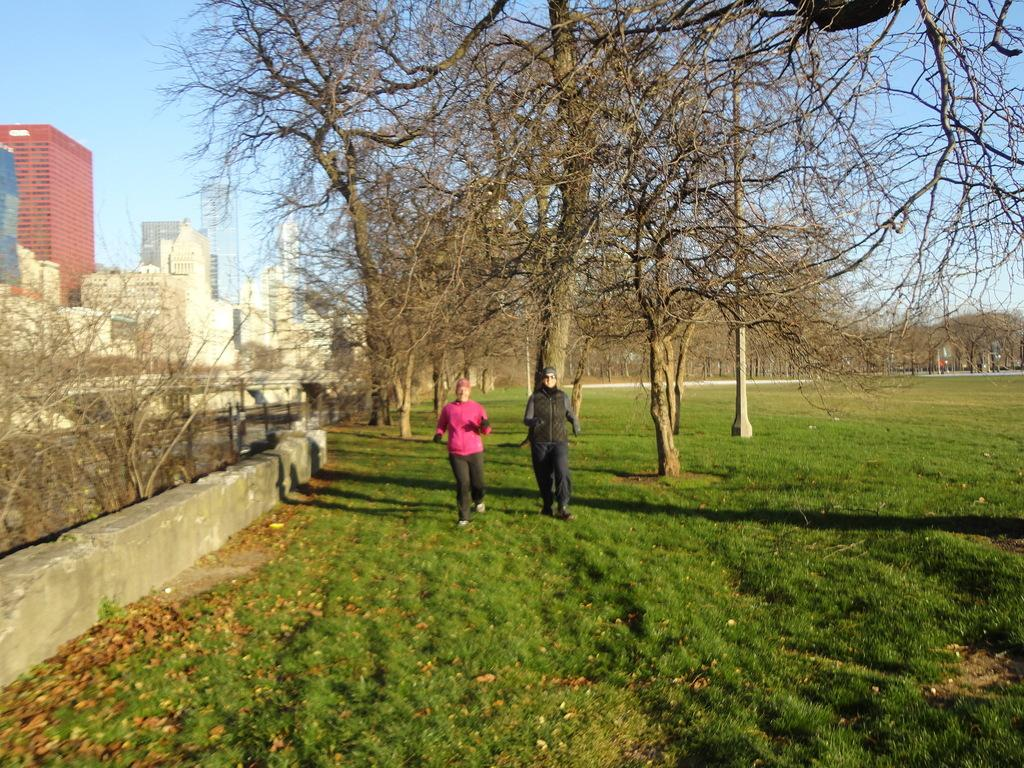How many people are present in the image? There are 2 persons in the image. What type of natural environment is visible in the image? There is green grass in the image. What can be seen in the background of the image? There are trees and buildings in the background of the image. What is the color of the sky in the background of the image? The sky is blue in the background of the image. What type of vessel is being used by the persons in the image? There is no vessel present in the image; the persons are standing on green grass. What type of vacation destination is depicted in the image? The image does not depict a specific vacation destination; it simply shows a scene with green grass, trees, buildings, and a blue sky. 